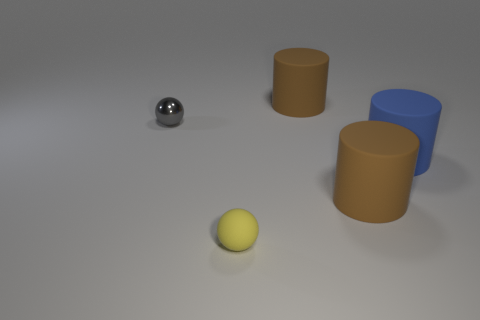What color is the ball that is made of the same material as the big blue cylinder?
Provide a succinct answer. Yellow. What number of yellow rubber spheres are the same size as the gray object?
Give a very brief answer. 1. How many blue things are either rubber spheres or small cylinders?
Give a very brief answer. 0. What number of things are small brown spheres or objects behind the small gray shiny ball?
Provide a succinct answer. 1. There is a yellow thing that is in front of the small shiny sphere; what is it made of?
Give a very brief answer. Rubber. Are there any rubber things of the same shape as the tiny shiny thing?
Provide a succinct answer. Yes. Is the material of the yellow ball the same as the blue cylinder that is to the right of the gray ball?
Your answer should be compact. Yes. What material is the brown cylinder that is in front of the small ball that is behind the small yellow matte sphere?
Make the answer very short. Rubber. Is the number of big cylinders that are in front of the big blue cylinder greater than the number of big blue shiny cylinders?
Your answer should be very brief. Yes. Are any large blue matte things visible?
Give a very brief answer. Yes. 